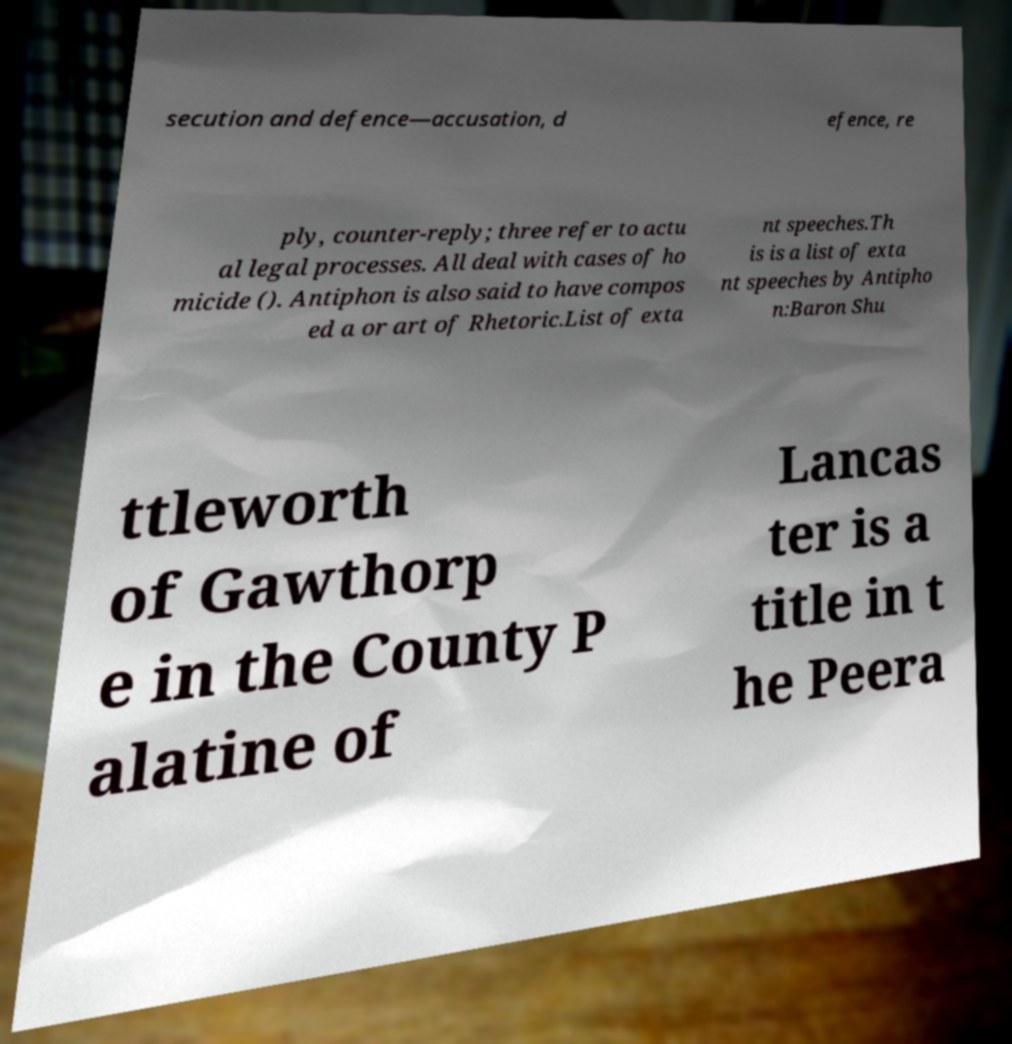For documentation purposes, I need the text within this image transcribed. Could you provide that? secution and defence—accusation, d efence, re ply, counter-reply; three refer to actu al legal processes. All deal with cases of ho micide (). Antiphon is also said to have compos ed a or art of Rhetoric.List of exta nt speeches.Th is is a list of exta nt speeches by Antipho n:Baron Shu ttleworth of Gawthorp e in the County P alatine of Lancas ter is a title in t he Peera 